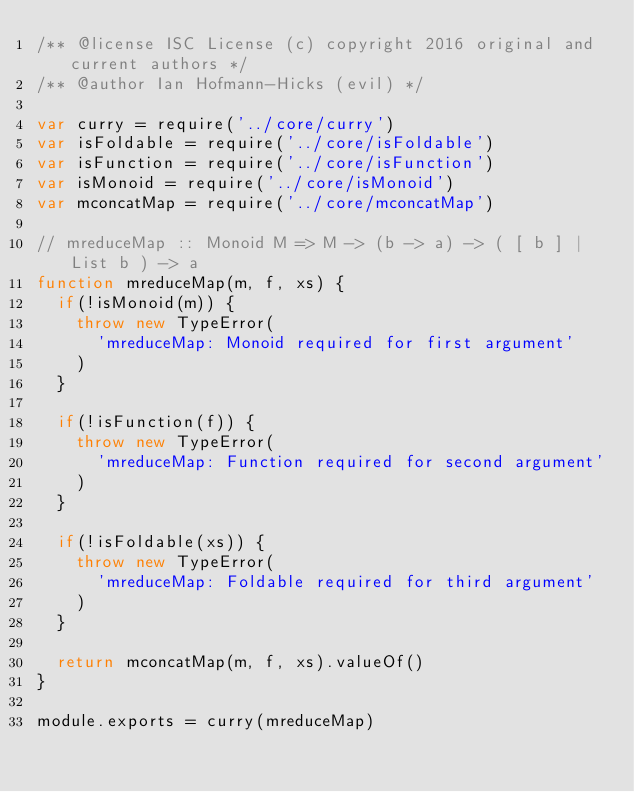<code> <loc_0><loc_0><loc_500><loc_500><_JavaScript_>/** @license ISC License (c) copyright 2016 original and current authors */
/** @author Ian Hofmann-Hicks (evil) */

var curry = require('../core/curry')
var isFoldable = require('../core/isFoldable')
var isFunction = require('../core/isFunction')
var isMonoid = require('../core/isMonoid')
var mconcatMap = require('../core/mconcatMap')

// mreduceMap :: Monoid M => M -> (b -> a) -> ( [ b ] | List b ) -> a
function mreduceMap(m, f, xs) {
  if(!isMonoid(m)) {
    throw new TypeError(
      'mreduceMap: Monoid required for first argument'
    )
  }

  if(!isFunction(f)) {
    throw new TypeError(
      'mreduceMap: Function required for second argument'
    )
  }

  if(!isFoldable(xs)) {
    throw new TypeError(
      'mreduceMap: Foldable required for third argument'
    )
  }

  return mconcatMap(m, f, xs).valueOf()
}

module.exports = curry(mreduceMap)
</code> 